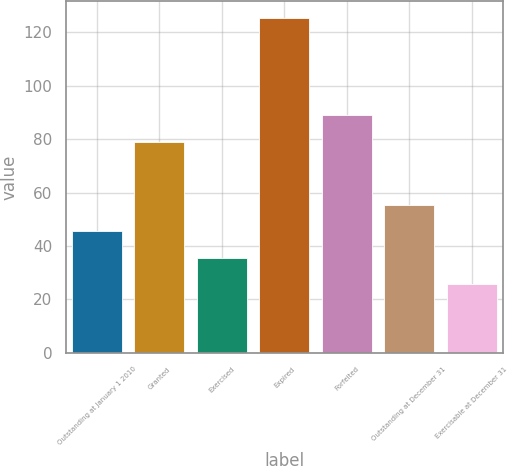Convert chart. <chart><loc_0><loc_0><loc_500><loc_500><bar_chart><fcel>Outstanding at January 1 2010<fcel>Granted<fcel>Exercised<fcel>Expired<fcel>Forfeited<fcel>Outstanding at December 31<fcel>Exercisable at December 31<nl><fcel>45.53<fcel>79.1<fcel>35.55<fcel>125.33<fcel>89.08<fcel>55.51<fcel>25.57<nl></chart> 